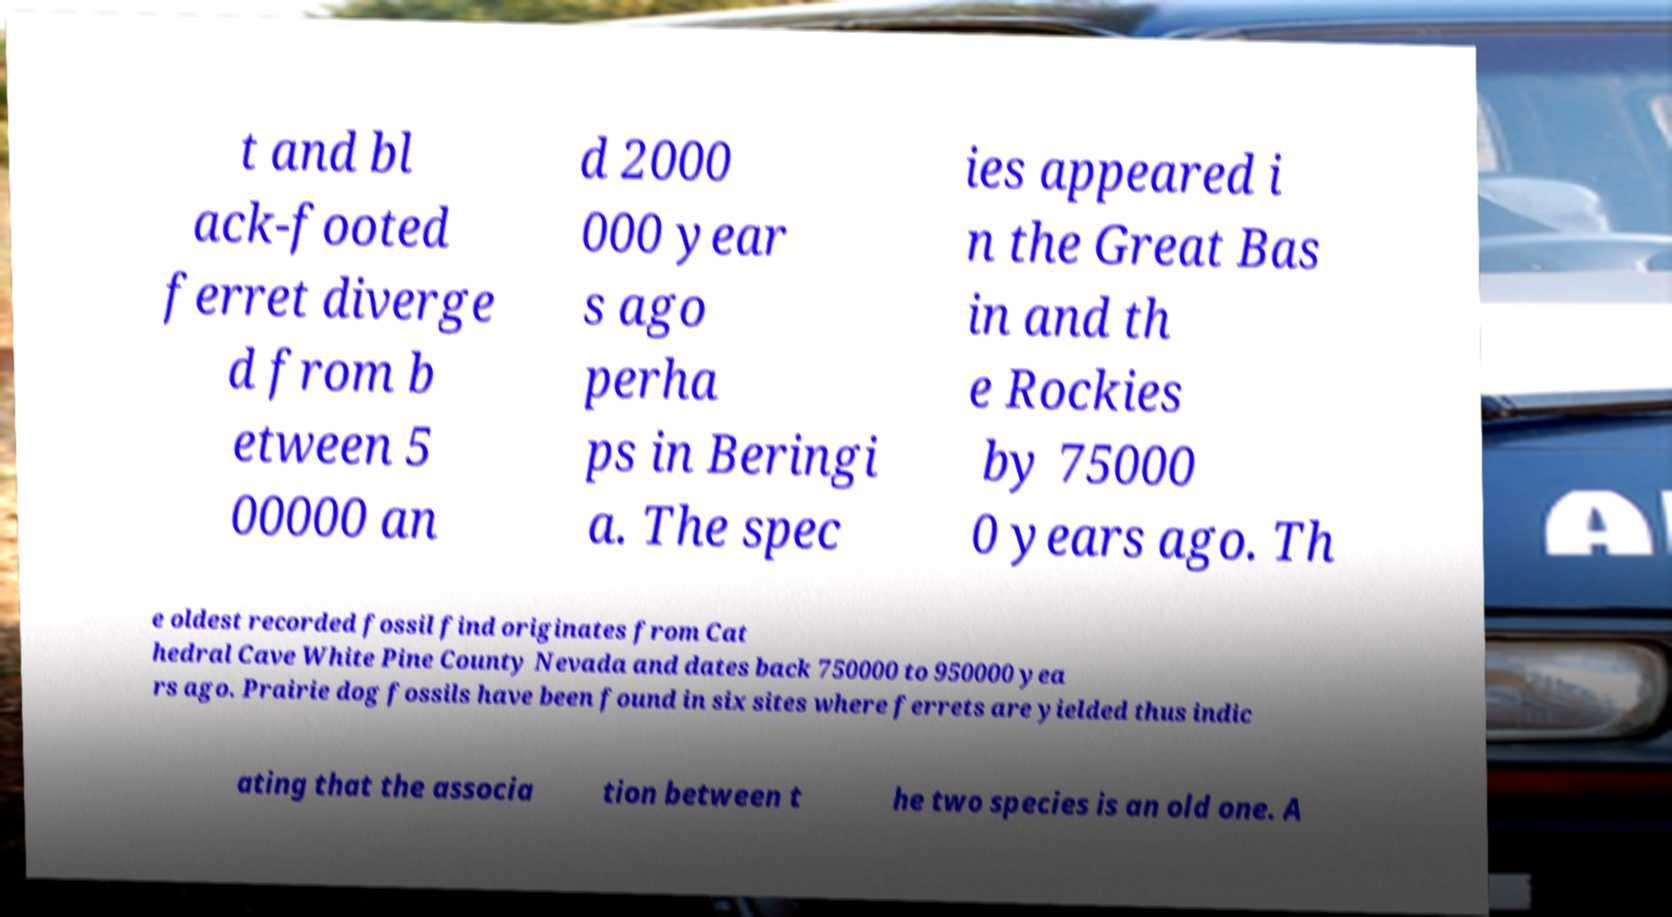I need the written content from this picture converted into text. Can you do that? t and bl ack-footed ferret diverge d from b etween 5 00000 an d 2000 000 year s ago perha ps in Beringi a. The spec ies appeared i n the Great Bas in and th e Rockies by 75000 0 years ago. Th e oldest recorded fossil find originates from Cat hedral Cave White Pine County Nevada and dates back 750000 to 950000 yea rs ago. Prairie dog fossils have been found in six sites where ferrets are yielded thus indic ating that the associa tion between t he two species is an old one. A 